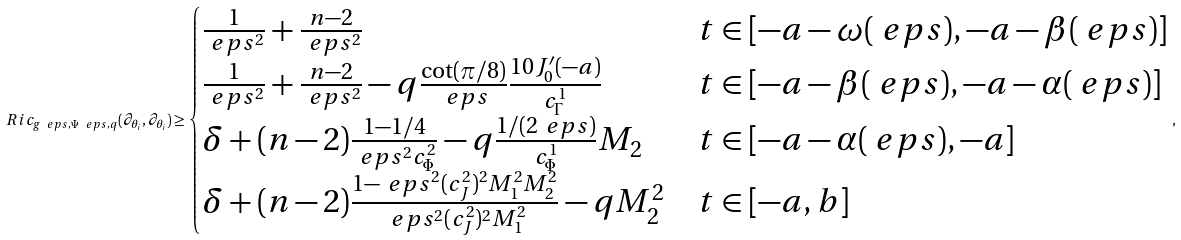<formula> <loc_0><loc_0><loc_500><loc_500>R i c _ { g _ { \ } e p s , \Psi _ { \ } e p s , q } ( \partial _ { \theta _ { i } } , \partial _ { \theta _ { i } } ) \geq \begin{cases} \frac { 1 } { \ e p s ^ { 2 } } + \frac { n - 2 } { \ e p s ^ { 2 } } & t \in [ - a - \omega ( \ e p s ) , - a - \beta ( \ e p s ) ] \\ \frac { 1 } { \ e p s ^ { 2 } } + \frac { n - 2 } { \ e p s ^ { 2 } } - q \frac { \cot ( \pi / 8 ) } { \ e p s } \frac { 1 0 J ^ { \prime } _ { 0 } ( - a ) } { c _ { \Gamma } ^ { 1 } } & t \in [ - a - \beta ( \ e p s ) , - a - \alpha ( \ e p s ) ] \\ \delta + ( n - 2 ) \frac { 1 - 1 / 4 } { \ e p s ^ { 2 } c _ { \Phi } ^ { 2 } } - q \frac { 1 / ( 2 \ e p s ) } { c _ { \Phi } ^ { 1 } } M _ { 2 } & t \in [ - a - \alpha ( \ e p s ) , - a ] \\ \delta + ( n - 2 ) \frac { 1 - \ e p s ^ { 2 } ( c _ { J } ^ { 2 } ) ^ { 2 } M _ { 1 } ^ { 2 } M _ { 2 } ^ { 2 } } { \ e p s ^ { 2 } ( c _ { J } ^ { 2 } ) ^ { 2 } M _ { 1 } ^ { 2 } } - q M _ { 2 } ^ { 2 } & t \in [ - a , b ] \end{cases} ,</formula> 